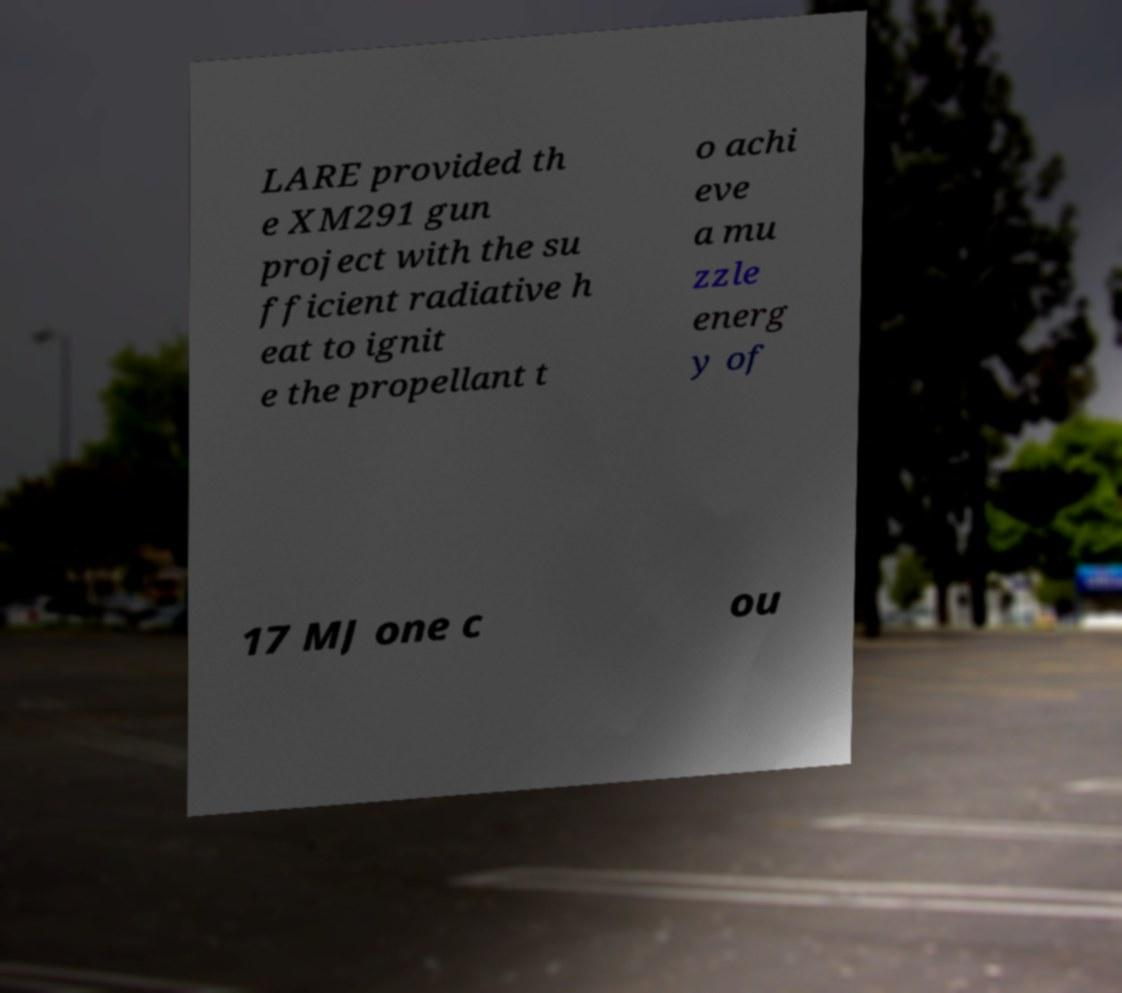Please read and relay the text visible in this image. What does it say? LARE provided th e XM291 gun project with the su fficient radiative h eat to ignit e the propellant t o achi eve a mu zzle energ y of 17 MJ one c ou 